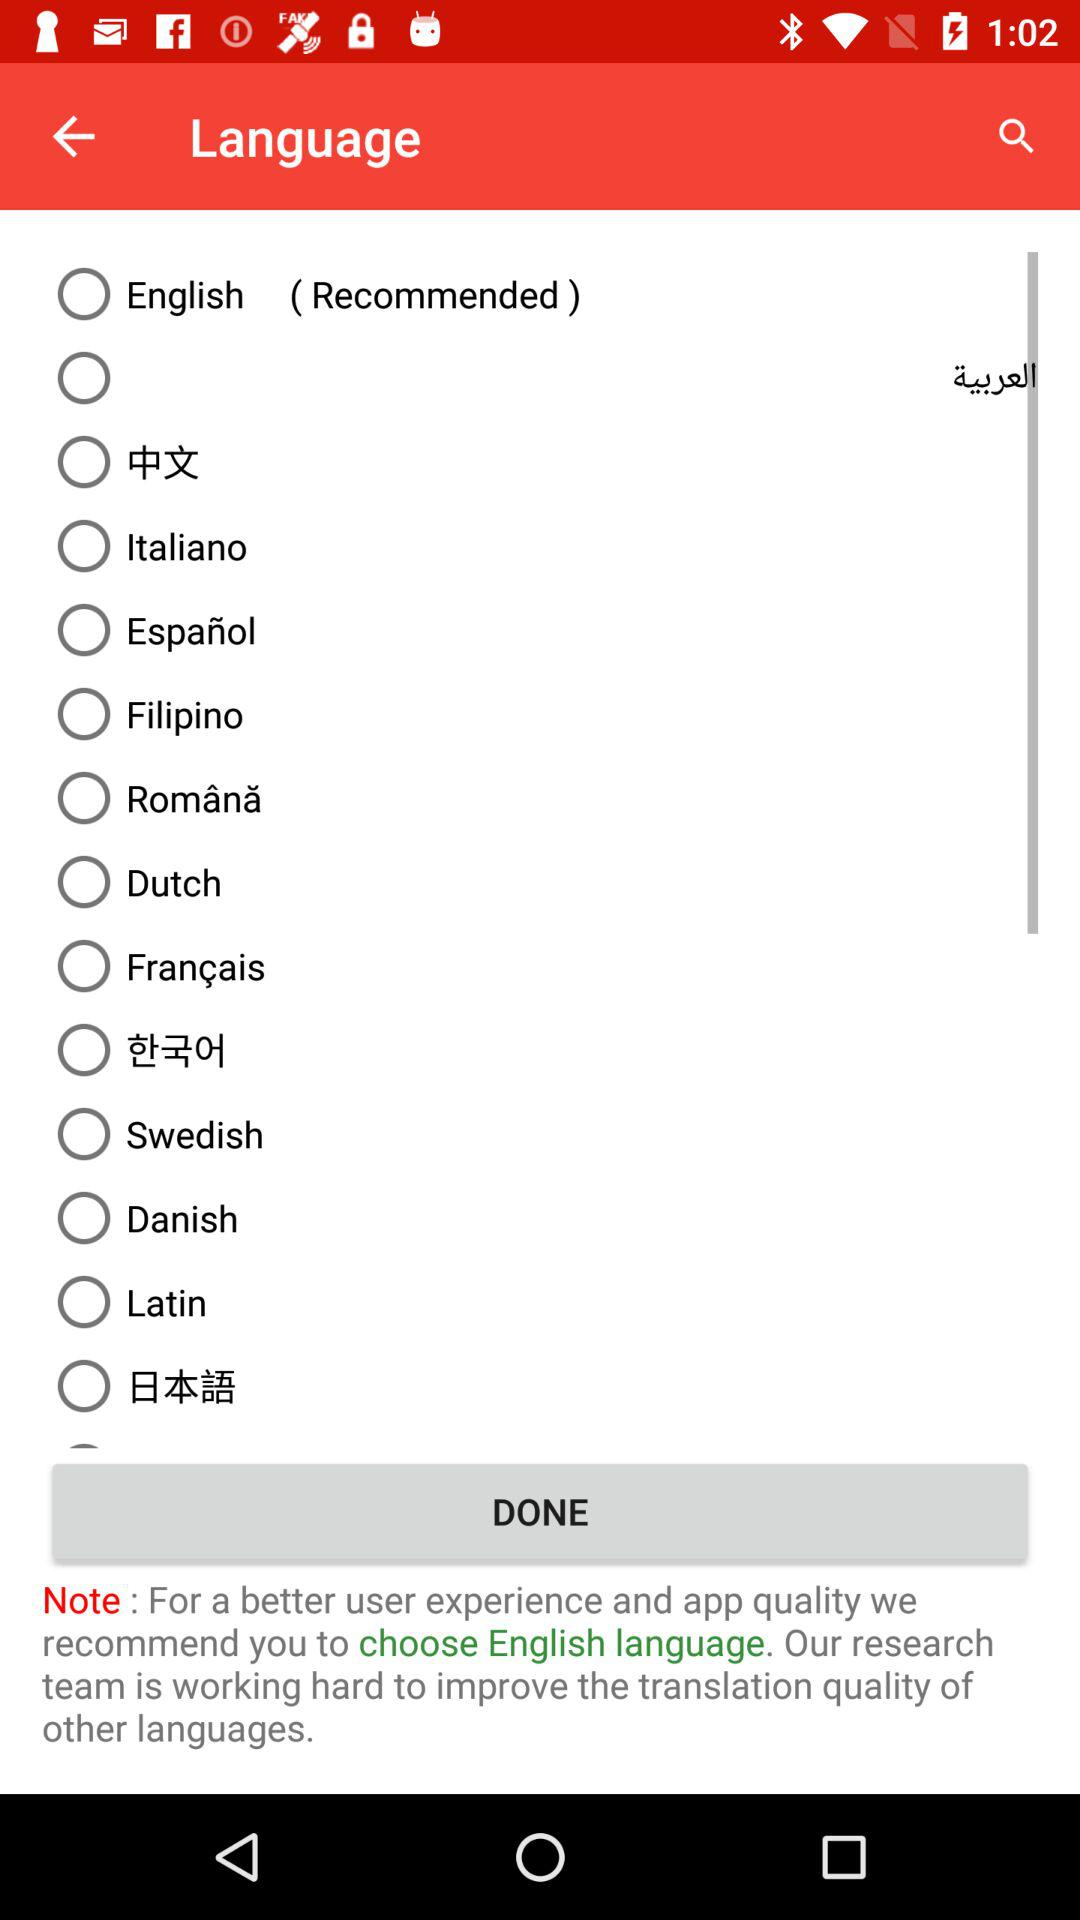Which is the recommended language? The recommended language is English. 